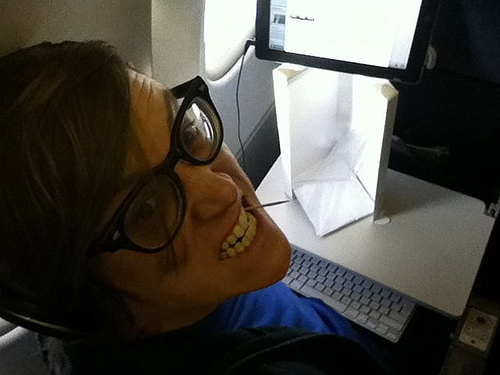Which color is the glass? The color of the glass is not black. It might be difficult to see its exact color in the image. 